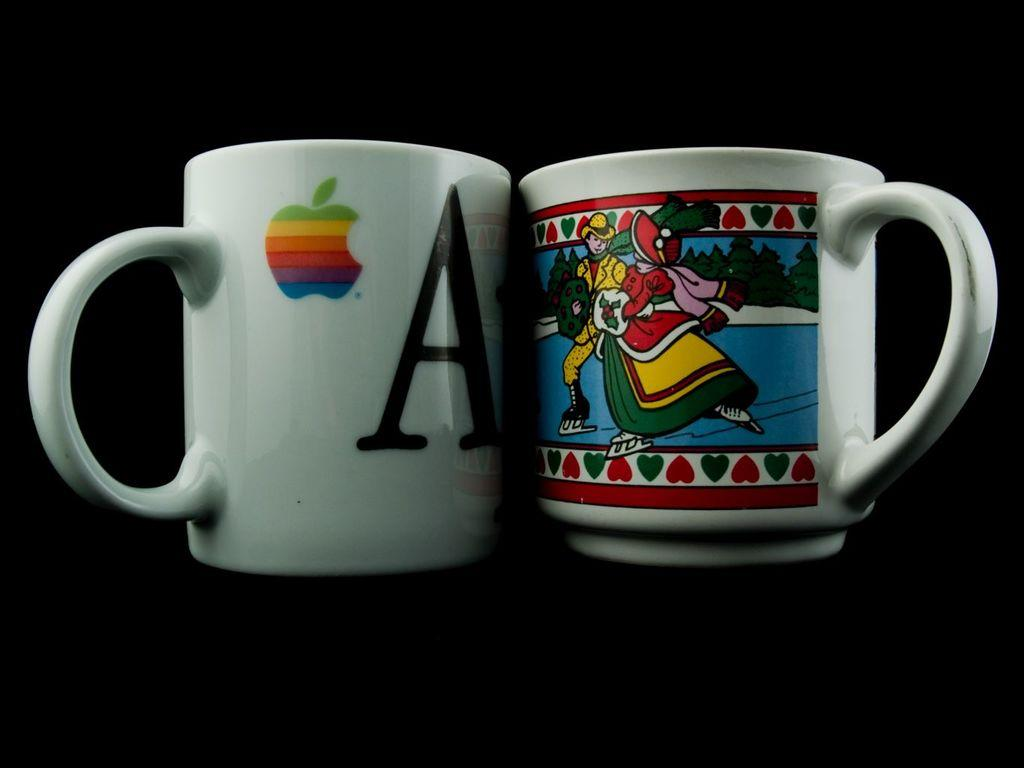<image>
Provide a brief description of the given image. Two coffee mugs and one has the letter A and the apple logo. 